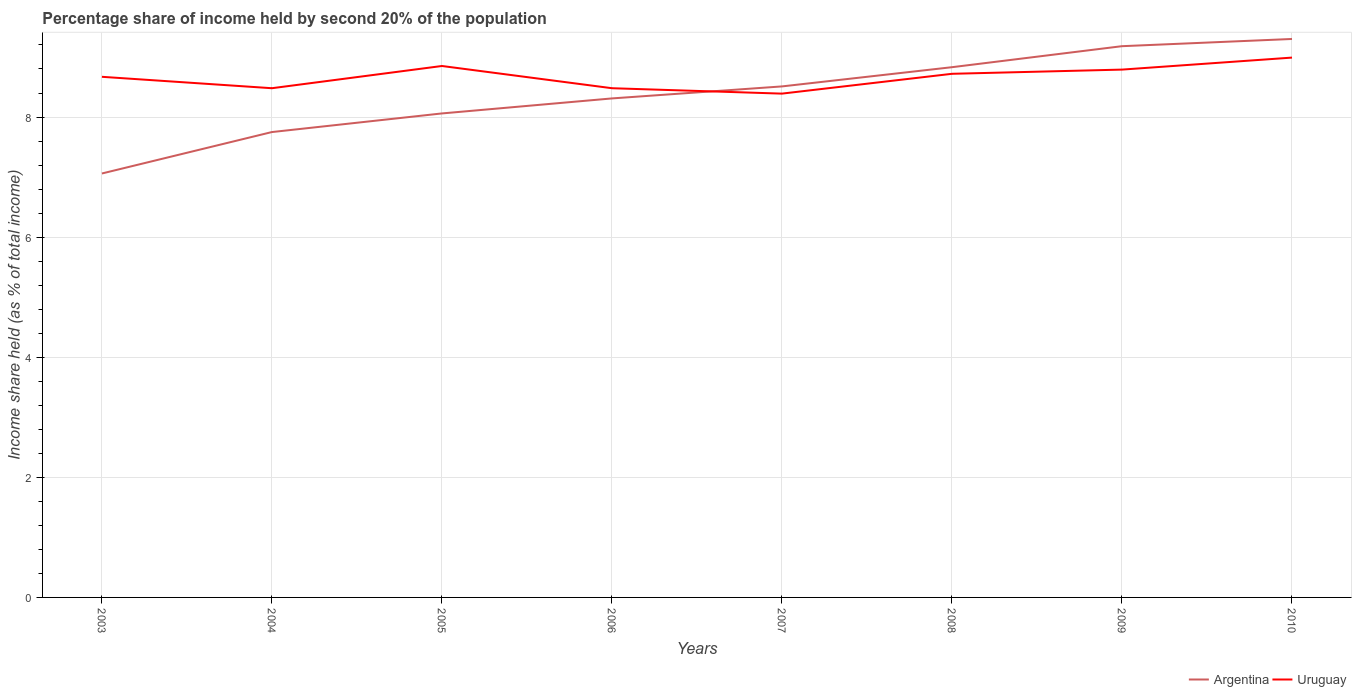How many different coloured lines are there?
Your answer should be very brief. 2. Does the line corresponding to Argentina intersect with the line corresponding to Uruguay?
Offer a terse response. Yes. Across all years, what is the maximum share of income held by second 20% of the population in Uruguay?
Offer a terse response. 8.39. In which year was the share of income held by second 20% of the population in Uruguay maximum?
Make the answer very short. 2007. What is the total share of income held by second 20% of the population in Argentina in the graph?
Ensure brevity in your answer.  -1.25. What is the difference between the highest and the second highest share of income held by second 20% of the population in Uruguay?
Provide a short and direct response. 0.6. How many lines are there?
Provide a succinct answer. 2. How many years are there in the graph?
Provide a succinct answer. 8. Are the values on the major ticks of Y-axis written in scientific E-notation?
Provide a succinct answer. No. Does the graph contain any zero values?
Your answer should be very brief. No. How many legend labels are there?
Keep it short and to the point. 2. What is the title of the graph?
Offer a very short reply. Percentage share of income held by second 20% of the population. Does "Heavily indebted poor countries" appear as one of the legend labels in the graph?
Your response must be concise. No. What is the label or title of the Y-axis?
Your answer should be very brief. Income share held (as % of total income). What is the Income share held (as % of total income) in Argentina in 2003?
Provide a succinct answer. 7.06. What is the Income share held (as % of total income) in Uruguay in 2003?
Offer a very short reply. 8.67. What is the Income share held (as % of total income) in Argentina in 2004?
Your answer should be compact. 7.75. What is the Income share held (as % of total income) of Uruguay in 2004?
Offer a terse response. 8.48. What is the Income share held (as % of total income) of Argentina in 2005?
Provide a short and direct response. 8.06. What is the Income share held (as % of total income) of Uruguay in 2005?
Make the answer very short. 8.85. What is the Income share held (as % of total income) in Argentina in 2006?
Ensure brevity in your answer.  8.31. What is the Income share held (as % of total income) of Uruguay in 2006?
Give a very brief answer. 8.48. What is the Income share held (as % of total income) in Argentina in 2007?
Your answer should be very brief. 8.51. What is the Income share held (as % of total income) in Uruguay in 2007?
Provide a succinct answer. 8.39. What is the Income share held (as % of total income) in Argentina in 2008?
Make the answer very short. 8.83. What is the Income share held (as % of total income) of Uruguay in 2008?
Offer a terse response. 8.72. What is the Income share held (as % of total income) in Argentina in 2009?
Offer a terse response. 9.18. What is the Income share held (as % of total income) of Uruguay in 2009?
Offer a very short reply. 8.79. What is the Income share held (as % of total income) of Uruguay in 2010?
Offer a very short reply. 8.99. Across all years, what is the maximum Income share held (as % of total income) in Argentina?
Ensure brevity in your answer.  9.3. Across all years, what is the maximum Income share held (as % of total income) in Uruguay?
Your answer should be very brief. 8.99. Across all years, what is the minimum Income share held (as % of total income) of Argentina?
Offer a very short reply. 7.06. Across all years, what is the minimum Income share held (as % of total income) in Uruguay?
Provide a short and direct response. 8.39. What is the total Income share held (as % of total income) of Uruguay in the graph?
Ensure brevity in your answer.  69.37. What is the difference between the Income share held (as % of total income) of Argentina in 2003 and that in 2004?
Provide a short and direct response. -0.69. What is the difference between the Income share held (as % of total income) of Uruguay in 2003 and that in 2004?
Offer a very short reply. 0.19. What is the difference between the Income share held (as % of total income) of Argentina in 2003 and that in 2005?
Provide a short and direct response. -1. What is the difference between the Income share held (as % of total income) in Uruguay in 2003 and that in 2005?
Ensure brevity in your answer.  -0.18. What is the difference between the Income share held (as % of total income) of Argentina in 2003 and that in 2006?
Your answer should be very brief. -1.25. What is the difference between the Income share held (as % of total income) in Uruguay in 2003 and that in 2006?
Your answer should be very brief. 0.19. What is the difference between the Income share held (as % of total income) in Argentina in 2003 and that in 2007?
Make the answer very short. -1.45. What is the difference between the Income share held (as % of total income) in Uruguay in 2003 and that in 2007?
Offer a terse response. 0.28. What is the difference between the Income share held (as % of total income) of Argentina in 2003 and that in 2008?
Your response must be concise. -1.77. What is the difference between the Income share held (as % of total income) of Argentina in 2003 and that in 2009?
Keep it short and to the point. -2.12. What is the difference between the Income share held (as % of total income) in Uruguay in 2003 and that in 2009?
Keep it short and to the point. -0.12. What is the difference between the Income share held (as % of total income) in Argentina in 2003 and that in 2010?
Give a very brief answer. -2.24. What is the difference between the Income share held (as % of total income) in Uruguay in 2003 and that in 2010?
Offer a very short reply. -0.32. What is the difference between the Income share held (as % of total income) of Argentina in 2004 and that in 2005?
Keep it short and to the point. -0.31. What is the difference between the Income share held (as % of total income) in Uruguay in 2004 and that in 2005?
Give a very brief answer. -0.37. What is the difference between the Income share held (as % of total income) in Argentina in 2004 and that in 2006?
Your answer should be very brief. -0.56. What is the difference between the Income share held (as % of total income) of Uruguay in 2004 and that in 2006?
Provide a short and direct response. 0. What is the difference between the Income share held (as % of total income) in Argentina in 2004 and that in 2007?
Your response must be concise. -0.76. What is the difference between the Income share held (as % of total income) of Uruguay in 2004 and that in 2007?
Your answer should be compact. 0.09. What is the difference between the Income share held (as % of total income) in Argentina in 2004 and that in 2008?
Give a very brief answer. -1.08. What is the difference between the Income share held (as % of total income) of Uruguay in 2004 and that in 2008?
Offer a terse response. -0.24. What is the difference between the Income share held (as % of total income) of Argentina in 2004 and that in 2009?
Keep it short and to the point. -1.43. What is the difference between the Income share held (as % of total income) in Uruguay in 2004 and that in 2009?
Keep it short and to the point. -0.31. What is the difference between the Income share held (as % of total income) of Argentina in 2004 and that in 2010?
Keep it short and to the point. -1.55. What is the difference between the Income share held (as % of total income) of Uruguay in 2004 and that in 2010?
Give a very brief answer. -0.51. What is the difference between the Income share held (as % of total income) in Uruguay in 2005 and that in 2006?
Ensure brevity in your answer.  0.37. What is the difference between the Income share held (as % of total income) of Argentina in 2005 and that in 2007?
Offer a terse response. -0.45. What is the difference between the Income share held (as % of total income) in Uruguay in 2005 and that in 2007?
Ensure brevity in your answer.  0.46. What is the difference between the Income share held (as % of total income) in Argentina in 2005 and that in 2008?
Ensure brevity in your answer.  -0.77. What is the difference between the Income share held (as % of total income) of Uruguay in 2005 and that in 2008?
Your answer should be very brief. 0.13. What is the difference between the Income share held (as % of total income) of Argentina in 2005 and that in 2009?
Provide a short and direct response. -1.12. What is the difference between the Income share held (as % of total income) of Argentina in 2005 and that in 2010?
Ensure brevity in your answer.  -1.24. What is the difference between the Income share held (as % of total income) in Uruguay in 2005 and that in 2010?
Offer a very short reply. -0.14. What is the difference between the Income share held (as % of total income) in Uruguay in 2006 and that in 2007?
Give a very brief answer. 0.09. What is the difference between the Income share held (as % of total income) of Argentina in 2006 and that in 2008?
Give a very brief answer. -0.52. What is the difference between the Income share held (as % of total income) of Uruguay in 2006 and that in 2008?
Ensure brevity in your answer.  -0.24. What is the difference between the Income share held (as % of total income) in Argentina in 2006 and that in 2009?
Keep it short and to the point. -0.87. What is the difference between the Income share held (as % of total income) of Uruguay in 2006 and that in 2009?
Offer a terse response. -0.31. What is the difference between the Income share held (as % of total income) in Argentina in 2006 and that in 2010?
Your response must be concise. -0.99. What is the difference between the Income share held (as % of total income) of Uruguay in 2006 and that in 2010?
Make the answer very short. -0.51. What is the difference between the Income share held (as % of total income) of Argentina in 2007 and that in 2008?
Offer a very short reply. -0.32. What is the difference between the Income share held (as % of total income) in Uruguay in 2007 and that in 2008?
Your response must be concise. -0.33. What is the difference between the Income share held (as % of total income) of Argentina in 2007 and that in 2009?
Your answer should be compact. -0.67. What is the difference between the Income share held (as % of total income) in Argentina in 2007 and that in 2010?
Your answer should be very brief. -0.79. What is the difference between the Income share held (as % of total income) in Uruguay in 2007 and that in 2010?
Give a very brief answer. -0.6. What is the difference between the Income share held (as % of total income) of Argentina in 2008 and that in 2009?
Provide a succinct answer. -0.35. What is the difference between the Income share held (as % of total income) of Uruguay in 2008 and that in 2009?
Provide a short and direct response. -0.07. What is the difference between the Income share held (as % of total income) in Argentina in 2008 and that in 2010?
Keep it short and to the point. -0.47. What is the difference between the Income share held (as % of total income) in Uruguay in 2008 and that in 2010?
Your response must be concise. -0.27. What is the difference between the Income share held (as % of total income) of Argentina in 2009 and that in 2010?
Your answer should be compact. -0.12. What is the difference between the Income share held (as % of total income) of Uruguay in 2009 and that in 2010?
Your answer should be compact. -0.2. What is the difference between the Income share held (as % of total income) of Argentina in 2003 and the Income share held (as % of total income) of Uruguay in 2004?
Give a very brief answer. -1.42. What is the difference between the Income share held (as % of total income) of Argentina in 2003 and the Income share held (as % of total income) of Uruguay in 2005?
Your answer should be compact. -1.79. What is the difference between the Income share held (as % of total income) of Argentina in 2003 and the Income share held (as % of total income) of Uruguay in 2006?
Your response must be concise. -1.42. What is the difference between the Income share held (as % of total income) of Argentina in 2003 and the Income share held (as % of total income) of Uruguay in 2007?
Make the answer very short. -1.33. What is the difference between the Income share held (as % of total income) in Argentina in 2003 and the Income share held (as % of total income) in Uruguay in 2008?
Your response must be concise. -1.66. What is the difference between the Income share held (as % of total income) in Argentina in 2003 and the Income share held (as % of total income) in Uruguay in 2009?
Offer a very short reply. -1.73. What is the difference between the Income share held (as % of total income) of Argentina in 2003 and the Income share held (as % of total income) of Uruguay in 2010?
Keep it short and to the point. -1.93. What is the difference between the Income share held (as % of total income) of Argentina in 2004 and the Income share held (as % of total income) of Uruguay in 2005?
Your answer should be very brief. -1.1. What is the difference between the Income share held (as % of total income) of Argentina in 2004 and the Income share held (as % of total income) of Uruguay in 2006?
Offer a terse response. -0.73. What is the difference between the Income share held (as % of total income) of Argentina in 2004 and the Income share held (as % of total income) of Uruguay in 2007?
Provide a succinct answer. -0.64. What is the difference between the Income share held (as % of total income) in Argentina in 2004 and the Income share held (as % of total income) in Uruguay in 2008?
Make the answer very short. -0.97. What is the difference between the Income share held (as % of total income) of Argentina in 2004 and the Income share held (as % of total income) of Uruguay in 2009?
Provide a short and direct response. -1.04. What is the difference between the Income share held (as % of total income) of Argentina in 2004 and the Income share held (as % of total income) of Uruguay in 2010?
Offer a very short reply. -1.24. What is the difference between the Income share held (as % of total income) of Argentina in 2005 and the Income share held (as % of total income) of Uruguay in 2006?
Give a very brief answer. -0.42. What is the difference between the Income share held (as % of total income) in Argentina in 2005 and the Income share held (as % of total income) in Uruguay in 2007?
Your answer should be compact. -0.33. What is the difference between the Income share held (as % of total income) of Argentina in 2005 and the Income share held (as % of total income) of Uruguay in 2008?
Provide a succinct answer. -0.66. What is the difference between the Income share held (as % of total income) in Argentina in 2005 and the Income share held (as % of total income) in Uruguay in 2009?
Offer a terse response. -0.73. What is the difference between the Income share held (as % of total income) in Argentina in 2005 and the Income share held (as % of total income) in Uruguay in 2010?
Offer a very short reply. -0.93. What is the difference between the Income share held (as % of total income) in Argentina in 2006 and the Income share held (as % of total income) in Uruguay in 2007?
Make the answer very short. -0.08. What is the difference between the Income share held (as % of total income) of Argentina in 2006 and the Income share held (as % of total income) of Uruguay in 2008?
Provide a succinct answer. -0.41. What is the difference between the Income share held (as % of total income) of Argentina in 2006 and the Income share held (as % of total income) of Uruguay in 2009?
Make the answer very short. -0.48. What is the difference between the Income share held (as % of total income) of Argentina in 2006 and the Income share held (as % of total income) of Uruguay in 2010?
Make the answer very short. -0.68. What is the difference between the Income share held (as % of total income) in Argentina in 2007 and the Income share held (as % of total income) in Uruguay in 2008?
Give a very brief answer. -0.21. What is the difference between the Income share held (as % of total income) in Argentina in 2007 and the Income share held (as % of total income) in Uruguay in 2009?
Give a very brief answer. -0.28. What is the difference between the Income share held (as % of total income) in Argentina in 2007 and the Income share held (as % of total income) in Uruguay in 2010?
Provide a succinct answer. -0.48. What is the difference between the Income share held (as % of total income) in Argentina in 2008 and the Income share held (as % of total income) in Uruguay in 2010?
Provide a short and direct response. -0.16. What is the difference between the Income share held (as % of total income) in Argentina in 2009 and the Income share held (as % of total income) in Uruguay in 2010?
Offer a terse response. 0.19. What is the average Income share held (as % of total income) in Argentina per year?
Keep it short and to the point. 8.38. What is the average Income share held (as % of total income) in Uruguay per year?
Ensure brevity in your answer.  8.67. In the year 2003, what is the difference between the Income share held (as % of total income) of Argentina and Income share held (as % of total income) of Uruguay?
Keep it short and to the point. -1.61. In the year 2004, what is the difference between the Income share held (as % of total income) in Argentina and Income share held (as % of total income) in Uruguay?
Provide a succinct answer. -0.73. In the year 2005, what is the difference between the Income share held (as % of total income) in Argentina and Income share held (as % of total income) in Uruguay?
Give a very brief answer. -0.79. In the year 2006, what is the difference between the Income share held (as % of total income) of Argentina and Income share held (as % of total income) of Uruguay?
Provide a succinct answer. -0.17. In the year 2007, what is the difference between the Income share held (as % of total income) in Argentina and Income share held (as % of total income) in Uruguay?
Keep it short and to the point. 0.12. In the year 2008, what is the difference between the Income share held (as % of total income) in Argentina and Income share held (as % of total income) in Uruguay?
Your answer should be very brief. 0.11. In the year 2009, what is the difference between the Income share held (as % of total income) in Argentina and Income share held (as % of total income) in Uruguay?
Provide a succinct answer. 0.39. In the year 2010, what is the difference between the Income share held (as % of total income) of Argentina and Income share held (as % of total income) of Uruguay?
Make the answer very short. 0.31. What is the ratio of the Income share held (as % of total income) in Argentina in 2003 to that in 2004?
Make the answer very short. 0.91. What is the ratio of the Income share held (as % of total income) in Uruguay in 2003 to that in 2004?
Provide a succinct answer. 1.02. What is the ratio of the Income share held (as % of total income) of Argentina in 2003 to that in 2005?
Provide a succinct answer. 0.88. What is the ratio of the Income share held (as % of total income) of Uruguay in 2003 to that in 2005?
Your answer should be compact. 0.98. What is the ratio of the Income share held (as % of total income) of Argentina in 2003 to that in 2006?
Your response must be concise. 0.85. What is the ratio of the Income share held (as % of total income) of Uruguay in 2003 to that in 2006?
Ensure brevity in your answer.  1.02. What is the ratio of the Income share held (as % of total income) in Argentina in 2003 to that in 2007?
Your answer should be compact. 0.83. What is the ratio of the Income share held (as % of total income) in Uruguay in 2003 to that in 2007?
Your response must be concise. 1.03. What is the ratio of the Income share held (as % of total income) in Argentina in 2003 to that in 2008?
Your answer should be compact. 0.8. What is the ratio of the Income share held (as % of total income) of Argentina in 2003 to that in 2009?
Provide a succinct answer. 0.77. What is the ratio of the Income share held (as % of total income) of Uruguay in 2003 to that in 2009?
Keep it short and to the point. 0.99. What is the ratio of the Income share held (as % of total income) in Argentina in 2003 to that in 2010?
Your answer should be compact. 0.76. What is the ratio of the Income share held (as % of total income) of Uruguay in 2003 to that in 2010?
Ensure brevity in your answer.  0.96. What is the ratio of the Income share held (as % of total income) of Argentina in 2004 to that in 2005?
Provide a succinct answer. 0.96. What is the ratio of the Income share held (as % of total income) of Uruguay in 2004 to that in 2005?
Make the answer very short. 0.96. What is the ratio of the Income share held (as % of total income) of Argentina in 2004 to that in 2006?
Offer a very short reply. 0.93. What is the ratio of the Income share held (as % of total income) of Uruguay in 2004 to that in 2006?
Make the answer very short. 1. What is the ratio of the Income share held (as % of total income) of Argentina in 2004 to that in 2007?
Provide a short and direct response. 0.91. What is the ratio of the Income share held (as % of total income) in Uruguay in 2004 to that in 2007?
Give a very brief answer. 1.01. What is the ratio of the Income share held (as % of total income) in Argentina in 2004 to that in 2008?
Offer a very short reply. 0.88. What is the ratio of the Income share held (as % of total income) of Uruguay in 2004 to that in 2008?
Provide a short and direct response. 0.97. What is the ratio of the Income share held (as % of total income) in Argentina in 2004 to that in 2009?
Offer a very short reply. 0.84. What is the ratio of the Income share held (as % of total income) in Uruguay in 2004 to that in 2009?
Your answer should be very brief. 0.96. What is the ratio of the Income share held (as % of total income) in Argentina in 2004 to that in 2010?
Your answer should be very brief. 0.83. What is the ratio of the Income share held (as % of total income) in Uruguay in 2004 to that in 2010?
Your answer should be compact. 0.94. What is the ratio of the Income share held (as % of total income) in Argentina in 2005 to that in 2006?
Make the answer very short. 0.97. What is the ratio of the Income share held (as % of total income) of Uruguay in 2005 to that in 2006?
Provide a short and direct response. 1.04. What is the ratio of the Income share held (as % of total income) in Argentina in 2005 to that in 2007?
Give a very brief answer. 0.95. What is the ratio of the Income share held (as % of total income) of Uruguay in 2005 to that in 2007?
Offer a very short reply. 1.05. What is the ratio of the Income share held (as % of total income) in Argentina in 2005 to that in 2008?
Provide a succinct answer. 0.91. What is the ratio of the Income share held (as % of total income) in Uruguay in 2005 to that in 2008?
Provide a short and direct response. 1.01. What is the ratio of the Income share held (as % of total income) in Argentina in 2005 to that in 2009?
Offer a terse response. 0.88. What is the ratio of the Income share held (as % of total income) of Uruguay in 2005 to that in 2009?
Give a very brief answer. 1.01. What is the ratio of the Income share held (as % of total income) of Argentina in 2005 to that in 2010?
Your answer should be very brief. 0.87. What is the ratio of the Income share held (as % of total income) of Uruguay in 2005 to that in 2010?
Give a very brief answer. 0.98. What is the ratio of the Income share held (as % of total income) in Argentina in 2006 to that in 2007?
Give a very brief answer. 0.98. What is the ratio of the Income share held (as % of total income) in Uruguay in 2006 to that in 2007?
Provide a succinct answer. 1.01. What is the ratio of the Income share held (as % of total income) of Argentina in 2006 to that in 2008?
Make the answer very short. 0.94. What is the ratio of the Income share held (as % of total income) of Uruguay in 2006 to that in 2008?
Give a very brief answer. 0.97. What is the ratio of the Income share held (as % of total income) in Argentina in 2006 to that in 2009?
Ensure brevity in your answer.  0.91. What is the ratio of the Income share held (as % of total income) in Uruguay in 2006 to that in 2009?
Your response must be concise. 0.96. What is the ratio of the Income share held (as % of total income) of Argentina in 2006 to that in 2010?
Provide a short and direct response. 0.89. What is the ratio of the Income share held (as % of total income) of Uruguay in 2006 to that in 2010?
Your answer should be compact. 0.94. What is the ratio of the Income share held (as % of total income) in Argentina in 2007 to that in 2008?
Make the answer very short. 0.96. What is the ratio of the Income share held (as % of total income) in Uruguay in 2007 to that in 2008?
Make the answer very short. 0.96. What is the ratio of the Income share held (as % of total income) in Argentina in 2007 to that in 2009?
Offer a terse response. 0.93. What is the ratio of the Income share held (as % of total income) in Uruguay in 2007 to that in 2009?
Ensure brevity in your answer.  0.95. What is the ratio of the Income share held (as % of total income) in Argentina in 2007 to that in 2010?
Offer a terse response. 0.92. What is the ratio of the Income share held (as % of total income) of Argentina in 2008 to that in 2009?
Give a very brief answer. 0.96. What is the ratio of the Income share held (as % of total income) of Argentina in 2008 to that in 2010?
Keep it short and to the point. 0.95. What is the ratio of the Income share held (as % of total income) of Uruguay in 2008 to that in 2010?
Provide a succinct answer. 0.97. What is the ratio of the Income share held (as % of total income) of Argentina in 2009 to that in 2010?
Provide a short and direct response. 0.99. What is the ratio of the Income share held (as % of total income) of Uruguay in 2009 to that in 2010?
Provide a succinct answer. 0.98. What is the difference between the highest and the second highest Income share held (as % of total income) of Argentina?
Your response must be concise. 0.12. What is the difference between the highest and the second highest Income share held (as % of total income) in Uruguay?
Give a very brief answer. 0.14. What is the difference between the highest and the lowest Income share held (as % of total income) of Argentina?
Offer a terse response. 2.24. 